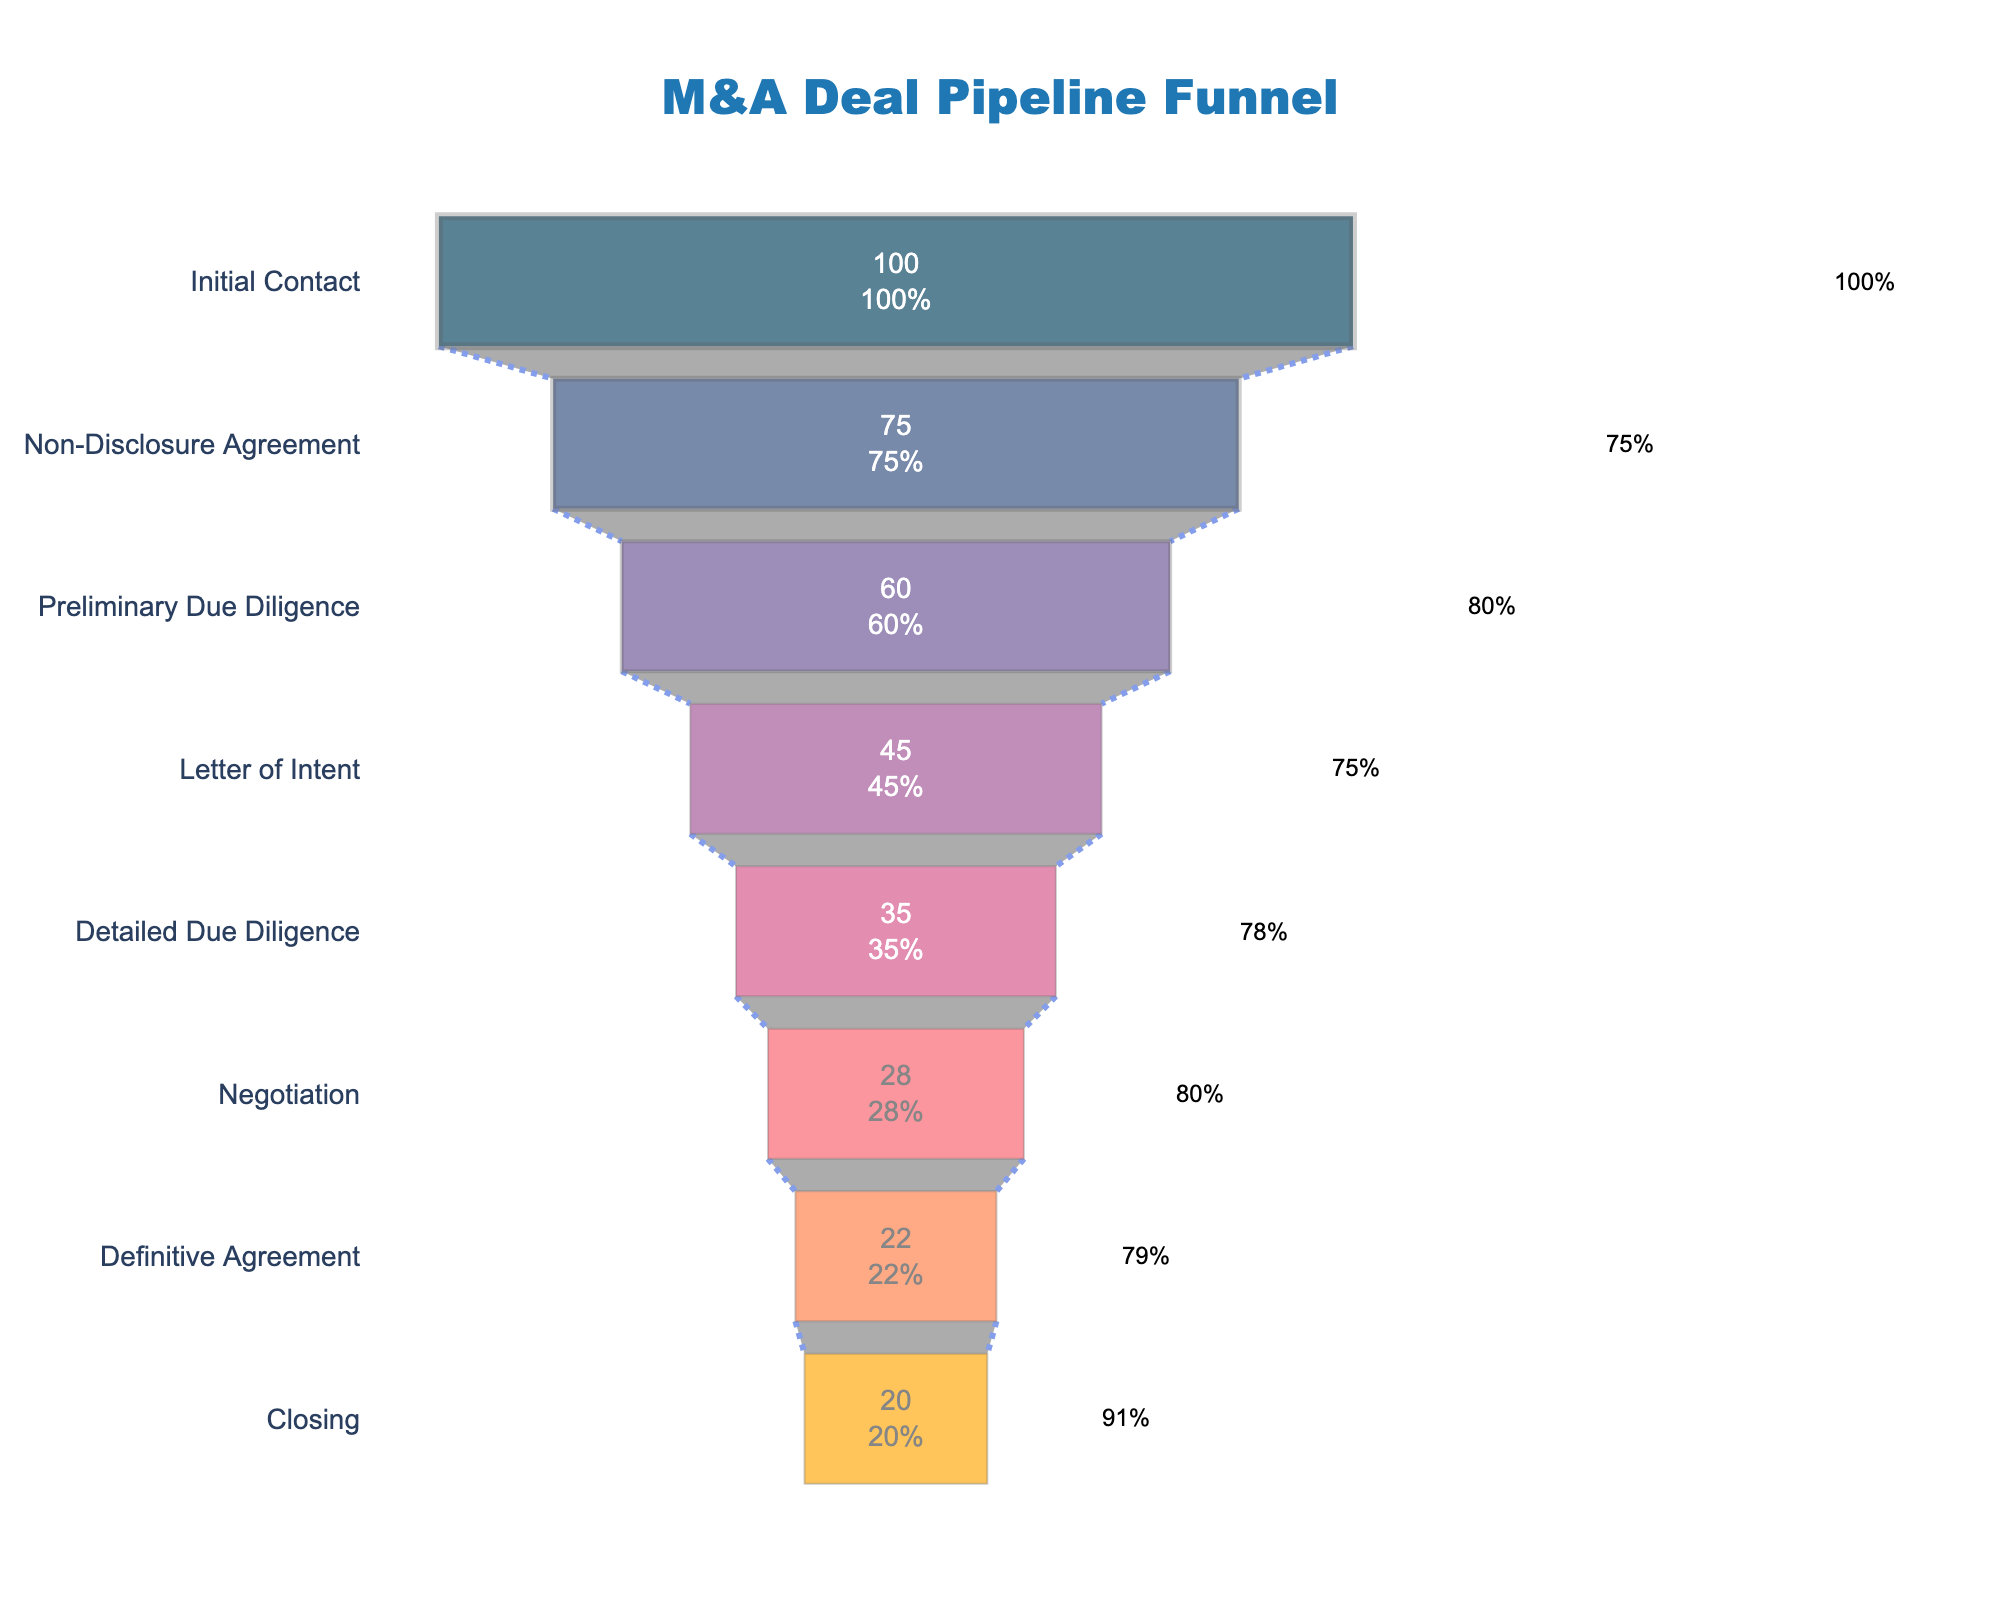What's the title of the funnel chart? The title of the chart is prominently displayed at the top and can be read directly from there.
Answer: M&A Deal Pipeline Funnel How many stages are there in the M&A Deal pipeline? Count the number of distinct stages presented on the y-axis.
Answer: 8 Which stage has the highest conversion rate? Identify the stage with the highest percentage value in the funnel chart. The conversion rate information is displayed for each stage directly on the chart.
Answer: Closing How does the number of deals change from Initial Contact to Non-Disclosure Agreement? Subtract the number of deals at Non-Disclosure Agreement from the number of deals at Initial Contact. Initial Contact has 100 deals and Non-Disclosure Agreement has 75.
Answer: 25 What is the conversion rate from Detailed Due Diligence to Negotiation? Locate the conversion rate value next to the stages Detailed Due Diligence and Negotiation on the chart.
Answer: 80% Which stage has the lowest number of deals? Identify the funnel segment with the smallest value for the number of deals. The number of deals is displayed inside each funnel segment.
Answer: Closing What is the average conversion rate across all stages? First, convert the percentage values to decimals and sum them. Then, divide by the number of stages. The stages are 100%, 75%, 80%, 75%, 78%, 80%, 79%, and 91%. The computation is as follows: (100 + 75 + 80 + 75 + 78 + 80 + 79 + 91) / 8.
Answer: 82.25% From which stage to which stage do we see the largest drop in the number of deals? Calculate the differences in the number of deals between consecutive stages and identify the largest drop. The differences are: 100-75, 75-60, 60-45, 45-35, 35-28, 28-22, and 22-20. The largest drop is from 45 to 35 (Letter of Intent to Detailed Due Diligence).
Answer: Letter of Intent to Detailed Due Diligence What's the overall conversion rate from Initial Contact to Closing? Calculate the ratio of the number of deals at the Closing stage to the number of deals at Initial Contact. The calculation is 20/100, then convert it to a percentage.
Answer: 20% 